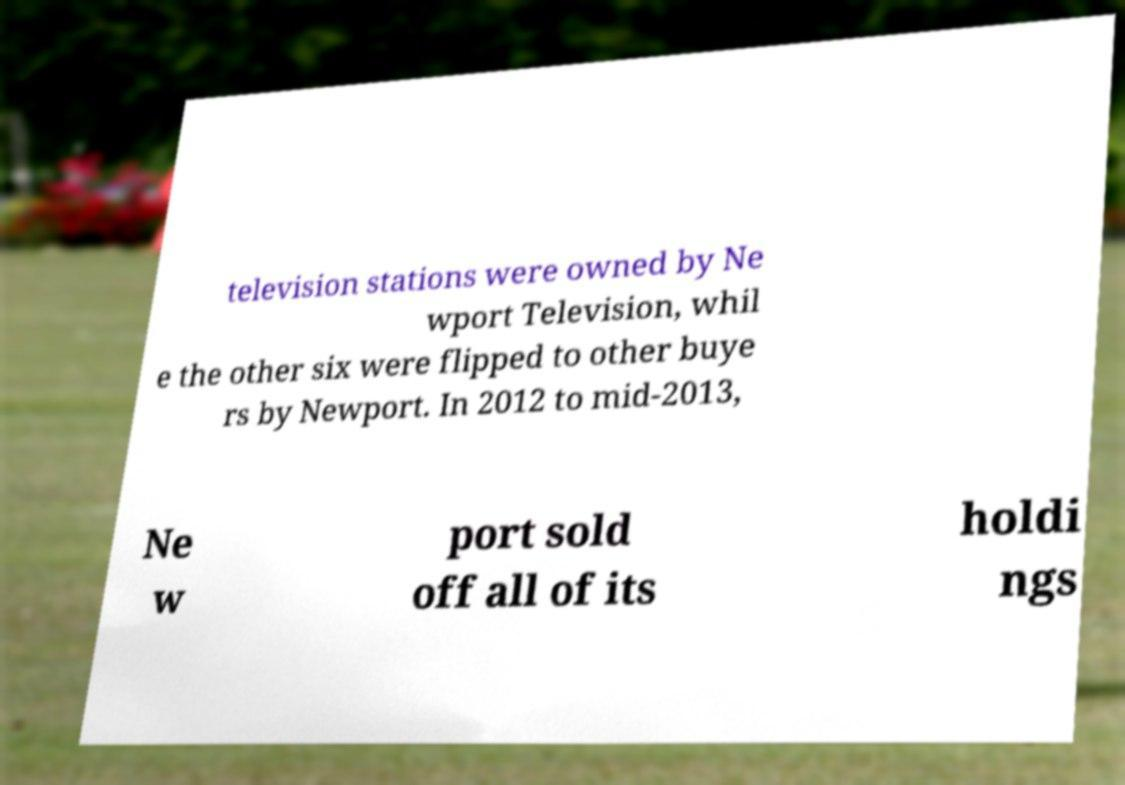For documentation purposes, I need the text within this image transcribed. Could you provide that? television stations were owned by Ne wport Television, whil e the other six were flipped to other buye rs by Newport. In 2012 to mid-2013, Ne w port sold off all of its holdi ngs 